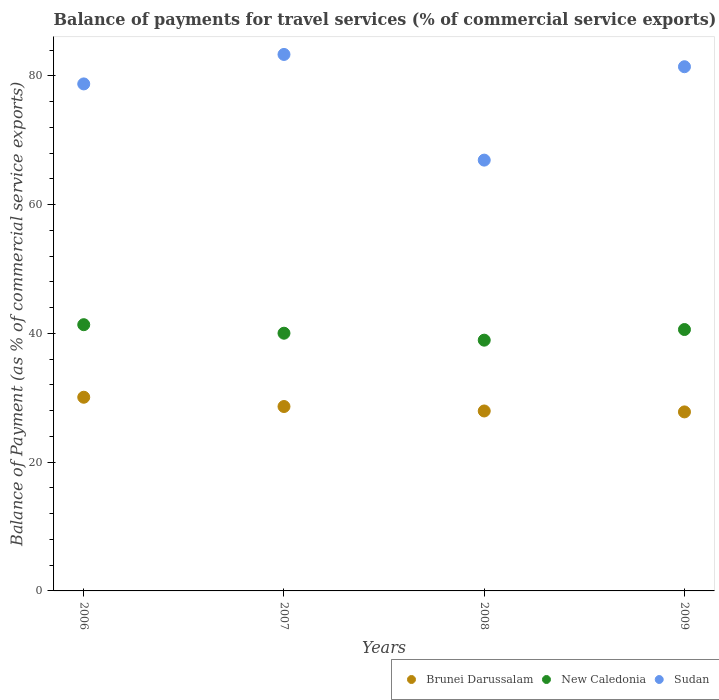How many different coloured dotlines are there?
Keep it short and to the point. 3. Is the number of dotlines equal to the number of legend labels?
Keep it short and to the point. Yes. What is the balance of payments for travel services in Sudan in 2008?
Offer a terse response. 66.91. Across all years, what is the maximum balance of payments for travel services in Brunei Darussalam?
Your answer should be very brief. 30.08. Across all years, what is the minimum balance of payments for travel services in Sudan?
Offer a terse response. 66.91. What is the total balance of payments for travel services in New Caledonia in the graph?
Your answer should be very brief. 160.92. What is the difference between the balance of payments for travel services in Brunei Darussalam in 2006 and that in 2007?
Ensure brevity in your answer.  1.44. What is the difference between the balance of payments for travel services in Sudan in 2008 and the balance of payments for travel services in Brunei Darussalam in 2009?
Your answer should be very brief. 39.1. What is the average balance of payments for travel services in Brunei Darussalam per year?
Offer a terse response. 28.62. In the year 2009, what is the difference between the balance of payments for travel services in Sudan and balance of payments for travel services in Brunei Darussalam?
Ensure brevity in your answer.  53.61. What is the ratio of the balance of payments for travel services in New Caledonia in 2008 to that in 2009?
Keep it short and to the point. 0.96. Is the balance of payments for travel services in Sudan in 2007 less than that in 2009?
Your response must be concise. No. Is the difference between the balance of payments for travel services in Sudan in 2008 and 2009 greater than the difference between the balance of payments for travel services in Brunei Darussalam in 2008 and 2009?
Provide a succinct answer. No. What is the difference between the highest and the second highest balance of payments for travel services in Sudan?
Your response must be concise. 1.91. What is the difference between the highest and the lowest balance of payments for travel services in Sudan?
Your answer should be compact. 16.41. Is it the case that in every year, the sum of the balance of payments for travel services in Sudan and balance of payments for travel services in New Caledonia  is greater than the balance of payments for travel services in Brunei Darussalam?
Offer a terse response. Yes. Is the balance of payments for travel services in New Caledonia strictly greater than the balance of payments for travel services in Sudan over the years?
Offer a very short reply. No. Is the balance of payments for travel services in Brunei Darussalam strictly less than the balance of payments for travel services in New Caledonia over the years?
Provide a succinct answer. Yes. How many dotlines are there?
Keep it short and to the point. 3. How many years are there in the graph?
Your answer should be very brief. 4. Are the values on the major ticks of Y-axis written in scientific E-notation?
Your response must be concise. No. Does the graph contain any zero values?
Your answer should be compact. No. Does the graph contain grids?
Give a very brief answer. No. What is the title of the graph?
Provide a succinct answer. Balance of payments for travel services (% of commercial service exports). Does "Marshall Islands" appear as one of the legend labels in the graph?
Your response must be concise. No. What is the label or title of the Y-axis?
Ensure brevity in your answer.  Balance of Payment (as % of commercial service exports). What is the Balance of Payment (as % of commercial service exports) in Brunei Darussalam in 2006?
Keep it short and to the point. 30.08. What is the Balance of Payment (as % of commercial service exports) in New Caledonia in 2006?
Your answer should be very brief. 41.35. What is the Balance of Payment (as % of commercial service exports) in Sudan in 2006?
Offer a terse response. 78.74. What is the Balance of Payment (as % of commercial service exports) in Brunei Darussalam in 2007?
Your response must be concise. 28.64. What is the Balance of Payment (as % of commercial service exports) in New Caledonia in 2007?
Provide a succinct answer. 40.02. What is the Balance of Payment (as % of commercial service exports) in Sudan in 2007?
Your response must be concise. 83.32. What is the Balance of Payment (as % of commercial service exports) of Brunei Darussalam in 2008?
Make the answer very short. 27.95. What is the Balance of Payment (as % of commercial service exports) in New Caledonia in 2008?
Your answer should be very brief. 38.95. What is the Balance of Payment (as % of commercial service exports) in Sudan in 2008?
Offer a very short reply. 66.91. What is the Balance of Payment (as % of commercial service exports) of Brunei Darussalam in 2009?
Provide a succinct answer. 27.8. What is the Balance of Payment (as % of commercial service exports) in New Caledonia in 2009?
Provide a succinct answer. 40.6. What is the Balance of Payment (as % of commercial service exports) in Sudan in 2009?
Make the answer very short. 81.41. Across all years, what is the maximum Balance of Payment (as % of commercial service exports) in Brunei Darussalam?
Provide a succinct answer. 30.08. Across all years, what is the maximum Balance of Payment (as % of commercial service exports) of New Caledonia?
Offer a terse response. 41.35. Across all years, what is the maximum Balance of Payment (as % of commercial service exports) in Sudan?
Keep it short and to the point. 83.32. Across all years, what is the minimum Balance of Payment (as % of commercial service exports) in Brunei Darussalam?
Keep it short and to the point. 27.8. Across all years, what is the minimum Balance of Payment (as % of commercial service exports) of New Caledonia?
Your answer should be very brief. 38.95. Across all years, what is the minimum Balance of Payment (as % of commercial service exports) of Sudan?
Offer a very short reply. 66.91. What is the total Balance of Payment (as % of commercial service exports) in Brunei Darussalam in the graph?
Provide a succinct answer. 114.47. What is the total Balance of Payment (as % of commercial service exports) of New Caledonia in the graph?
Ensure brevity in your answer.  160.92. What is the total Balance of Payment (as % of commercial service exports) in Sudan in the graph?
Offer a very short reply. 310.38. What is the difference between the Balance of Payment (as % of commercial service exports) of Brunei Darussalam in 2006 and that in 2007?
Provide a succinct answer. 1.44. What is the difference between the Balance of Payment (as % of commercial service exports) in New Caledonia in 2006 and that in 2007?
Ensure brevity in your answer.  1.32. What is the difference between the Balance of Payment (as % of commercial service exports) in Sudan in 2006 and that in 2007?
Ensure brevity in your answer.  -4.58. What is the difference between the Balance of Payment (as % of commercial service exports) of Brunei Darussalam in 2006 and that in 2008?
Offer a very short reply. 2.13. What is the difference between the Balance of Payment (as % of commercial service exports) of New Caledonia in 2006 and that in 2008?
Offer a very short reply. 2.4. What is the difference between the Balance of Payment (as % of commercial service exports) of Sudan in 2006 and that in 2008?
Provide a succinct answer. 11.84. What is the difference between the Balance of Payment (as % of commercial service exports) of Brunei Darussalam in 2006 and that in 2009?
Provide a succinct answer. 2.28. What is the difference between the Balance of Payment (as % of commercial service exports) of New Caledonia in 2006 and that in 2009?
Ensure brevity in your answer.  0.75. What is the difference between the Balance of Payment (as % of commercial service exports) in Sudan in 2006 and that in 2009?
Keep it short and to the point. -2.67. What is the difference between the Balance of Payment (as % of commercial service exports) of Brunei Darussalam in 2007 and that in 2008?
Make the answer very short. 0.69. What is the difference between the Balance of Payment (as % of commercial service exports) of New Caledonia in 2007 and that in 2008?
Make the answer very short. 1.08. What is the difference between the Balance of Payment (as % of commercial service exports) of Sudan in 2007 and that in 2008?
Provide a short and direct response. 16.41. What is the difference between the Balance of Payment (as % of commercial service exports) in Brunei Darussalam in 2007 and that in 2009?
Provide a short and direct response. 0.84. What is the difference between the Balance of Payment (as % of commercial service exports) in New Caledonia in 2007 and that in 2009?
Your answer should be very brief. -0.57. What is the difference between the Balance of Payment (as % of commercial service exports) of Sudan in 2007 and that in 2009?
Offer a terse response. 1.91. What is the difference between the Balance of Payment (as % of commercial service exports) of Brunei Darussalam in 2008 and that in 2009?
Your response must be concise. 0.14. What is the difference between the Balance of Payment (as % of commercial service exports) in New Caledonia in 2008 and that in 2009?
Offer a terse response. -1.65. What is the difference between the Balance of Payment (as % of commercial service exports) of Sudan in 2008 and that in 2009?
Ensure brevity in your answer.  -14.51. What is the difference between the Balance of Payment (as % of commercial service exports) in Brunei Darussalam in 2006 and the Balance of Payment (as % of commercial service exports) in New Caledonia in 2007?
Ensure brevity in your answer.  -9.94. What is the difference between the Balance of Payment (as % of commercial service exports) of Brunei Darussalam in 2006 and the Balance of Payment (as % of commercial service exports) of Sudan in 2007?
Make the answer very short. -53.24. What is the difference between the Balance of Payment (as % of commercial service exports) of New Caledonia in 2006 and the Balance of Payment (as % of commercial service exports) of Sudan in 2007?
Provide a short and direct response. -41.97. What is the difference between the Balance of Payment (as % of commercial service exports) in Brunei Darussalam in 2006 and the Balance of Payment (as % of commercial service exports) in New Caledonia in 2008?
Offer a terse response. -8.86. What is the difference between the Balance of Payment (as % of commercial service exports) in Brunei Darussalam in 2006 and the Balance of Payment (as % of commercial service exports) in Sudan in 2008?
Provide a succinct answer. -36.83. What is the difference between the Balance of Payment (as % of commercial service exports) in New Caledonia in 2006 and the Balance of Payment (as % of commercial service exports) in Sudan in 2008?
Give a very brief answer. -25.56. What is the difference between the Balance of Payment (as % of commercial service exports) in Brunei Darussalam in 2006 and the Balance of Payment (as % of commercial service exports) in New Caledonia in 2009?
Your answer should be very brief. -10.52. What is the difference between the Balance of Payment (as % of commercial service exports) in Brunei Darussalam in 2006 and the Balance of Payment (as % of commercial service exports) in Sudan in 2009?
Make the answer very short. -51.33. What is the difference between the Balance of Payment (as % of commercial service exports) in New Caledonia in 2006 and the Balance of Payment (as % of commercial service exports) in Sudan in 2009?
Your answer should be very brief. -40.07. What is the difference between the Balance of Payment (as % of commercial service exports) in Brunei Darussalam in 2007 and the Balance of Payment (as % of commercial service exports) in New Caledonia in 2008?
Offer a very short reply. -10.31. What is the difference between the Balance of Payment (as % of commercial service exports) of Brunei Darussalam in 2007 and the Balance of Payment (as % of commercial service exports) of Sudan in 2008?
Ensure brevity in your answer.  -38.27. What is the difference between the Balance of Payment (as % of commercial service exports) of New Caledonia in 2007 and the Balance of Payment (as % of commercial service exports) of Sudan in 2008?
Offer a terse response. -26.88. What is the difference between the Balance of Payment (as % of commercial service exports) in Brunei Darussalam in 2007 and the Balance of Payment (as % of commercial service exports) in New Caledonia in 2009?
Offer a very short reply. -11.96. What is the difference between the Balance of Payment (as % of commercial service exports) in Brunei Darussalam in 2007 and the Balance of Payment (as % of commercial service exports) in Sudan in 2009?
Offer a very short reply. -52.77. What is the difference between the Balance of Payment (as % of commercial service exports) of New Caledonia in 2007 and the Balance of Payment (as % of commercial service exports) of Sudan in 2009?
Ensure brevity in your answer.  -41.39. What is the difference between the Balance of Payment (as % of commercial service exports) in Brunei Darussalam in 2008 and the Balance of Payment (as % of commercial service exports) in New Caledonia in 2009?
Provide a short and direct response. -12.65. What is the difference between the Balance of Payment (as % of commercial service exports) in Brunei Darussalam in 2008 and the Balance of Payment (as % of commercial service exports) in Sudan in 2009?
Ensure brevity in your answer.  -53.47. What is the difference between the Balance of Payment (as % of commercial service exports) in New Caledonia in 2008 and the Balance of Payment (as % of commercial service exports) in Sudan in 2009?
Provide a succinct answer. -42.47. What is the average Balance of Payment (as % of commercial service exports) in Brunei Darussalam per year?
Offer a terse response. 28.62. What is the average Balance of Payment (as % of commercial service exports) of New Caledonia per year?
Provide a succinct answer. 40.23. What is the average Balance of Payment (as % of commercial service exports) in Sudan per year?
Your response must be concise. 77.6. In the year 2006, what is the difference between the Balance of Payment (as % of commercial service exports) of Brunei Darussalam and Balance of Payment (as % of commercial service exports) of New Caledonia?
Ensure brevity in your answer.  -11.27. In the year 2006, what is the difference between the Balance of Payment (as % of commercial service exports) in Brunei Darussalam and Balance of Payment (as % of commercial service exports) in Sudan?
Your response must be concise. -48.66. In the year 2006, what is the difference between the Balance of Payment (as % of commercial service exports) of New Caledonia and Balance of Payment (as % of commercial service exports) of Sudan?
Keep it short and to the point. -37.4. In the year 2007, what is the difference between the Balance of Payment (as % of commercial service exports) of Brunei Darussalam and Balance of Payment (as % of commercial service exports) of New Caledonia?
Give a very brief answer. -11.38. In the year 2007, what is the difference between the Balance of Payment (as % of commercial service exports) in Brunei Darussalam and Balance of Payment (as % of commercial service exports) in Sudan?
Give a very brief answer. -54.68. In the year 2007, what is the difference between the Balance of Payment (as % of commercial service exports) in New Caledonia and Balance of Payment (as % of commercial service exports) in Sudan?
Your answer should be very brief. -43.29. In the year 2008, what is the difference between the Balance of Payment (as % of commercial service exports) in Brunei Darussalam and Balance of Payment (as % of commercial service exports) in New Caledonia?
Offer a terse response. -11. In the year 2008, what is the difference between the Balance of Payment (as % of commercial service exports) of Brunei Darussalam and Balance of Payment (as % of commercial service exports) of Sudan?
Provide a short and direct response. -38.96. In the year 2008, what is the difference between the Balance of Payment (as % of commercial service exports) of New Caledonia and Balance of Payment (as % of commercial service exports) of Sudan?
Provide a short and direct response. -27.96. In the year 2009, what is the difference between the Balance of Payment (as % of commercial service exports) in Brunei Darussalam and Balance of Payment (as % of commercial service exports) in New Caledonia?
Your response must be concise. -12.79. In the year 2009, what is the difference between the Balance of Payment (as % of commercial service exports) of Brunei Darussalam and Balance of Payment (as % of commercial service exports) of Sudan?
Make the answer very short. -53.61. In the year 2009, what is the difference between the Balance of Payment (as % of commercial service exports) of New Caledonia and Balance of Payment (as % of commercial service exports) of Sudan?
Your response must be concise. -40.82. What is the ratio of the Balance of Payment (as % of commercial service exports) in Brunei Darussalam in 2006 to that in 2007?
Ensure brevity in your answer.  1.05. What is the ratio of the Balance of Payment (as % of commercial service exports) in New Caledonia in 2006 to that in 2007?
Make the answer very short. 1.03. What is the ratio of the Balance of Payment (as % of commercial service exports) of Sudan in 2006 to that in 2007?
Make the answer very short. 0.95. What is the ratio of the Balance of Payment (as % of commercial service exports) in Brunei Darussalam in 2006 to that in 2008?
Make the answer very short. 1.08. What is the ratio of the Balance of Payment (as % of commercial service exports) of New Caledonia in 2006 to that in 2008?
Your response must be concise. 1.06. What is the ratio of the Balance of Payment (as % of commercial service exports) of Sudan in 2006 to that in 2008?
Ensure brevity in your answer.  1.18. What is the ratio of the Balance of Payment (as % of commercial service exports) of Brunei Darussalam in 2006 to that in 2009?
Make the answer very short. 1.08. What is the ratio of the Balance of Payment (as % of commercial service exports) of New Caledonia in 2006 to that in 2009?
Your response must be concise. 1.02. What is the ratio of the Balance of Payment (as % of commercial service exports) in Sudan in 2006 to that in 2009?
Give a very brief answer. 0.97. What is the ratio of the Balance of Payment (as % of commercial service exports) in Brunei Darussalam in 2007 to that in 2008?
Keep it short and to the point. 1.02. What is the ratio of the Balance of Payment (as % of commercial service exports) in New Caledonia in 2007 to that in 2008?
Offer a terse response. 1.03. What is the ratio of the Balance of Payment (as % of commercial service exports) in Sudan in 2007 to that in 2008?
Keep it short and to the point. 1.25. What is the ratio of the Balance of Payment (as % of commercial service exports) in Brunei Darussalam in 2007 to that in 2009?
Your answer should be compact. 1.03. What is the ratio of the Balance of Payment (as % of commercial service exports) in New Caledonia in 2007 to that in 2009?
Your answer should be compact. 0.99. What is the ratio of the Balance of Payment (as % of commercial service exports) in Sudan in 2007 to that in 2009?
Your answer should be very brief. 1.02. What is the ratio of the Balance of Payment (as % of commercial service exports) in Brunei Darussalam in 2008 to that in 2009?
Ensure brevity in your answer.  1.01. What is the ratio of the Balance of Payment (as % of commercial service exports) in New Caledonia in 2008 to that in 2009?
Offer a very short reply. 0.96. What is the ratio of the Balance of Payment (as % of commercial service exports) of Sudan in 2008 to that in 2009?
Ensure brevity in your answer.  0.82. What is the difference between the highest and the second highest Balance of Payment (as % of commercial service exports) in Brunei Darussalam?
Make the answer very short. 1.44. What is the difference between the highest and the second highest Balance of Payment (as % of commercial service exports) in New Caledonia?
Give a very brief answer. 0.75. What is the difference between the highest and the second highest Balance of Payment (as % of commercial service exports) of Sudan?
Make the answer very short. 1.91. What is the difference between the highest and the lowest Balance of Payment (as % of commercial service exports) in Brunei Darussalam?
Provide a short and direct response. 2.28. What is the difference between the highest and the lowest Balance of Payment (as % of commercial service exports) of New Caledonia?
Offer a terse response. 2.4. What is the difference between the highest and the lowest Balance of Payment (as % of commercial service exports) in Sudan?
Give a very brief answer. 16.41. 